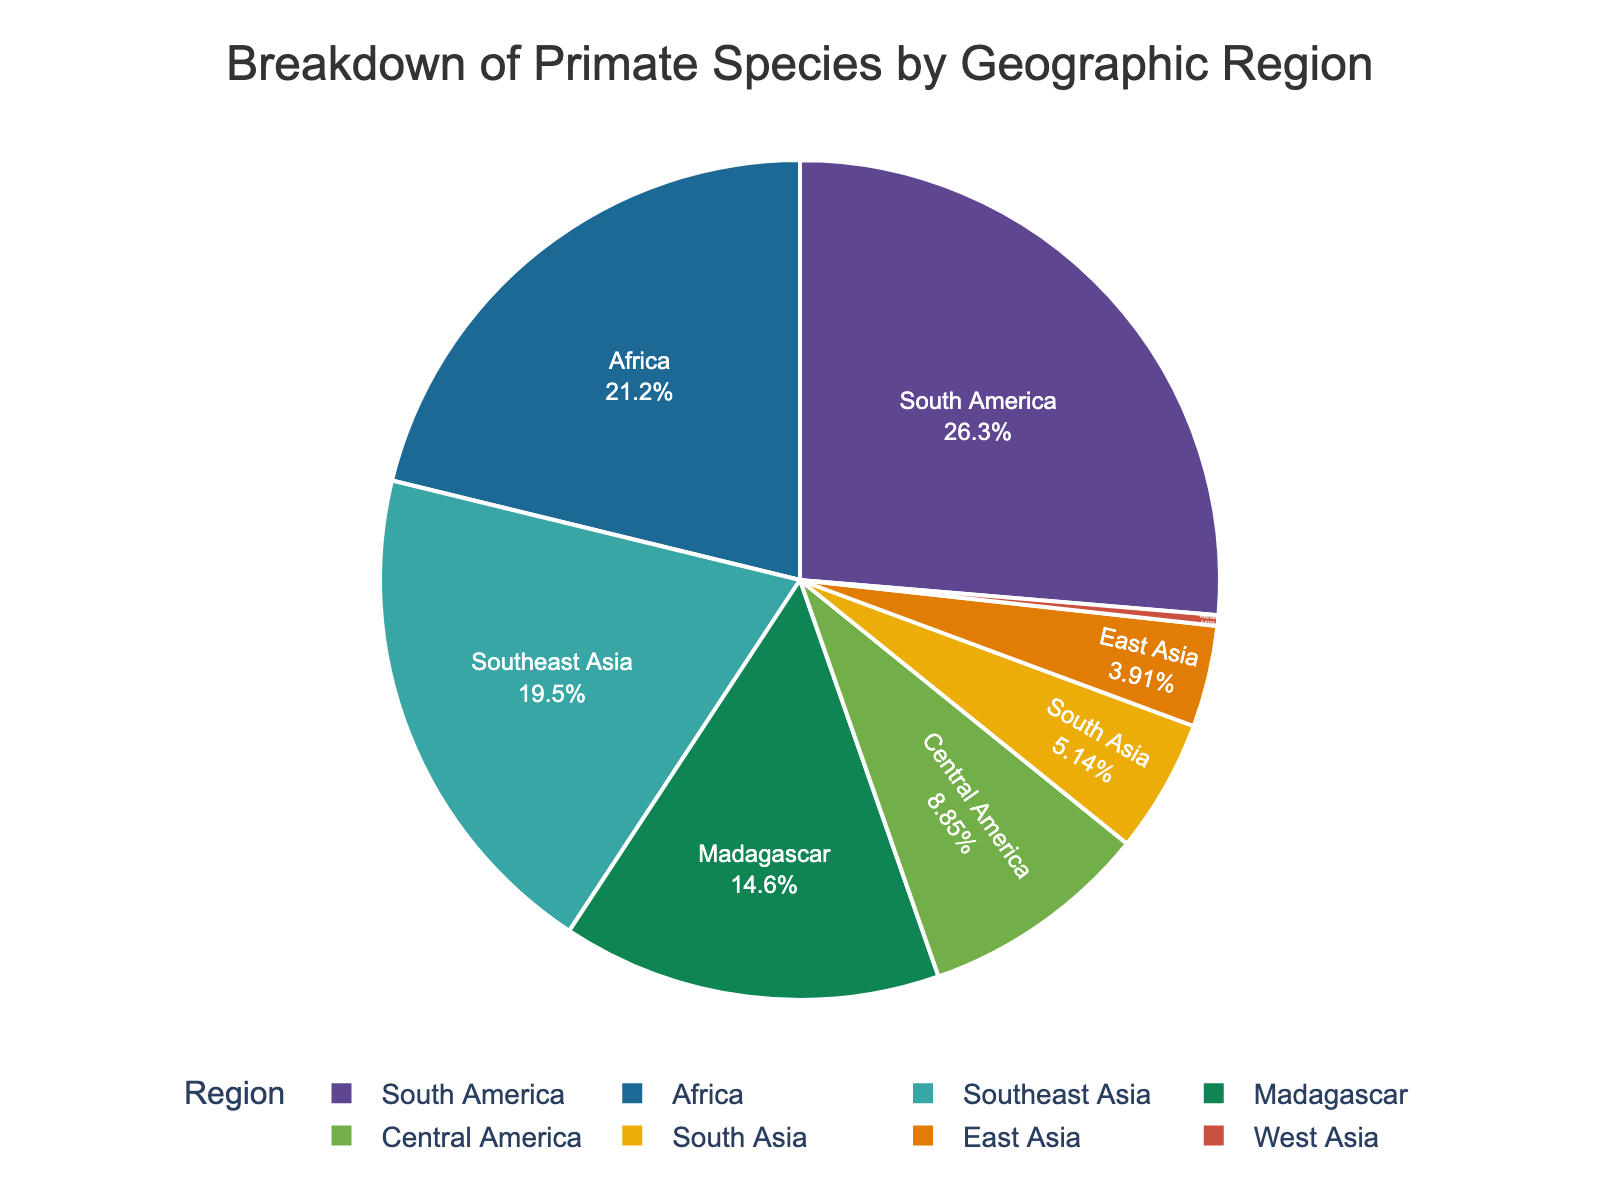What percentage of primate species are found in South America? Look at the segment labeled "South America" in the pie chart and check the percentage displayed within the segment.
Answer: 29.89% Which region has the fewest number of primate species? Identify the smallest segment in the pie chart and look for the corresponding label, which indicates the region with the fewest species.
Answer: West Asia Are there more primate species in Africa or Southeast Asia? Compare the sizes of the segments labeled "Africa" and "Southeast Asia" to see which one is larger. Africa has more species than Southeast Asia.
Answer: Africa What is the combined percentage of primate species in Central America and South Asia? Find the segments labeled "Central America" and "South Asia," sum their percentages: Central America (10.04%) + South Asia (5.83%) = 15.87%.
Answer: 15.87% Which region has the highest number of primate species? Identify the largest segment in the pie chart and look for the corresponding label, indicating the region with the highest species number.
Answer: South America How does the number of primate species in Madagascar compare to Southeast Asia? Look at the segments labeled "Madagascar" and "Southeast Asia" and compare their sizes; Madagascar has fewer species than Southeast Asia.
Answer: Southeast Asia What percentage of primate species are found in East Asia? Look at the segment labeled "East Asia" in the pie chart and check the percentage displayed within the segment.
Answer: 4.44% What is the difference in the number of primate species between South America and Africa? Subtract the number of species in Africa from that in South America: 128 (South America) - 103 (Africa) = 25.
Answer: 25 Which region represents approximately one-fourth of all primate species? Find the segment whose size represents roughly one-fourth (25%) of the pie chart; this is South America.
Answer: South America What is the total percentage of primate species found in Asia regions (Southeast Asia, South Asia, East Asia, West Asia)? Sum the percentages for these regions: Southeast Asia (22.19%) + South Asia (5.83%) + East Asia (4.44%) + West Asia (0.47%) = 32.93%.
Answer: 32.93% 